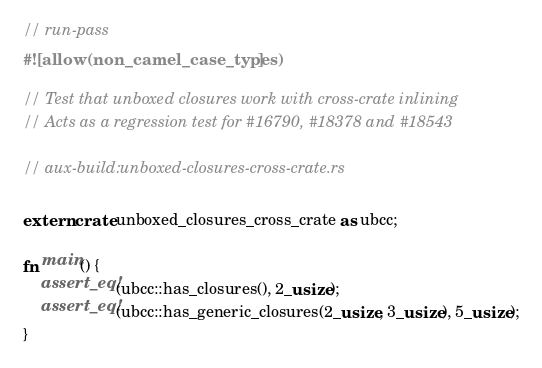<code> <loc_0><loc_0><loc_500><loc_500><_Rust_>// run-pass
#![allow(non_camel_case_types)]

// Test that unboxed closures work with cross-crate inlining
// Acts as a regression test for #16790, #18378 and #18543

// aux-build:unboxed-closures-cross-crate.rs

extern crate unboxed_closures_cross_crate as ubcc;

fn main() {
    assert_eq!(ubcc::has_closures(), 2_usize);
    assert_eq!(ubcc::has_generic_closures(2_usize, 3_usize), 5_usize);
}
</code> 